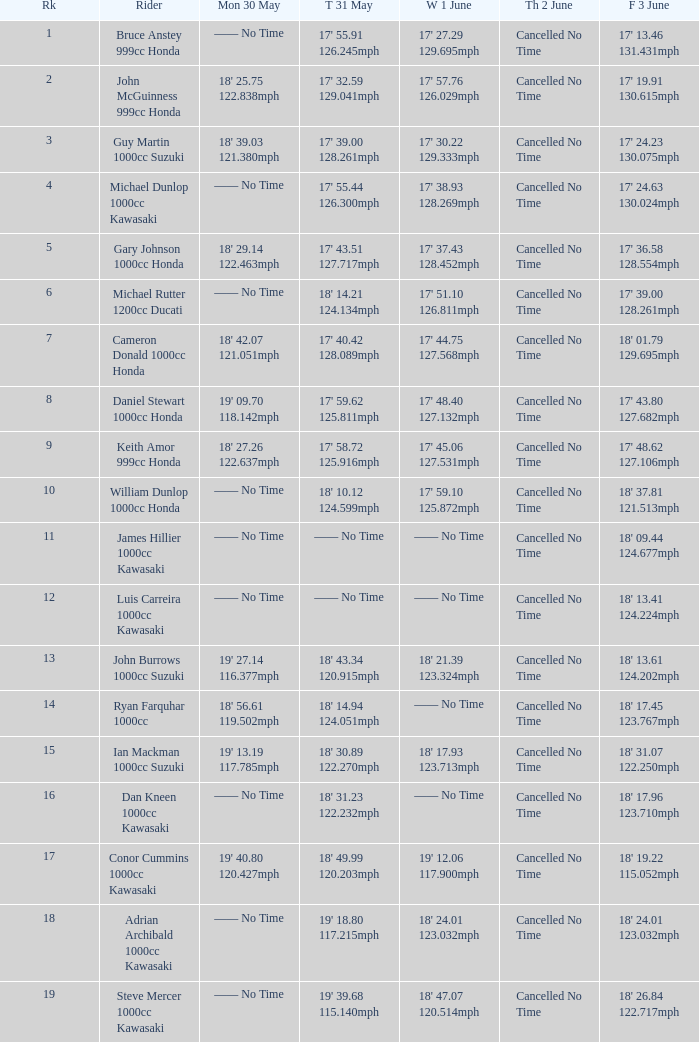What is the Mon 30 May time for the rider whose Fri 3 June time was 17' 13.46 131.431mph? —— No Time. 